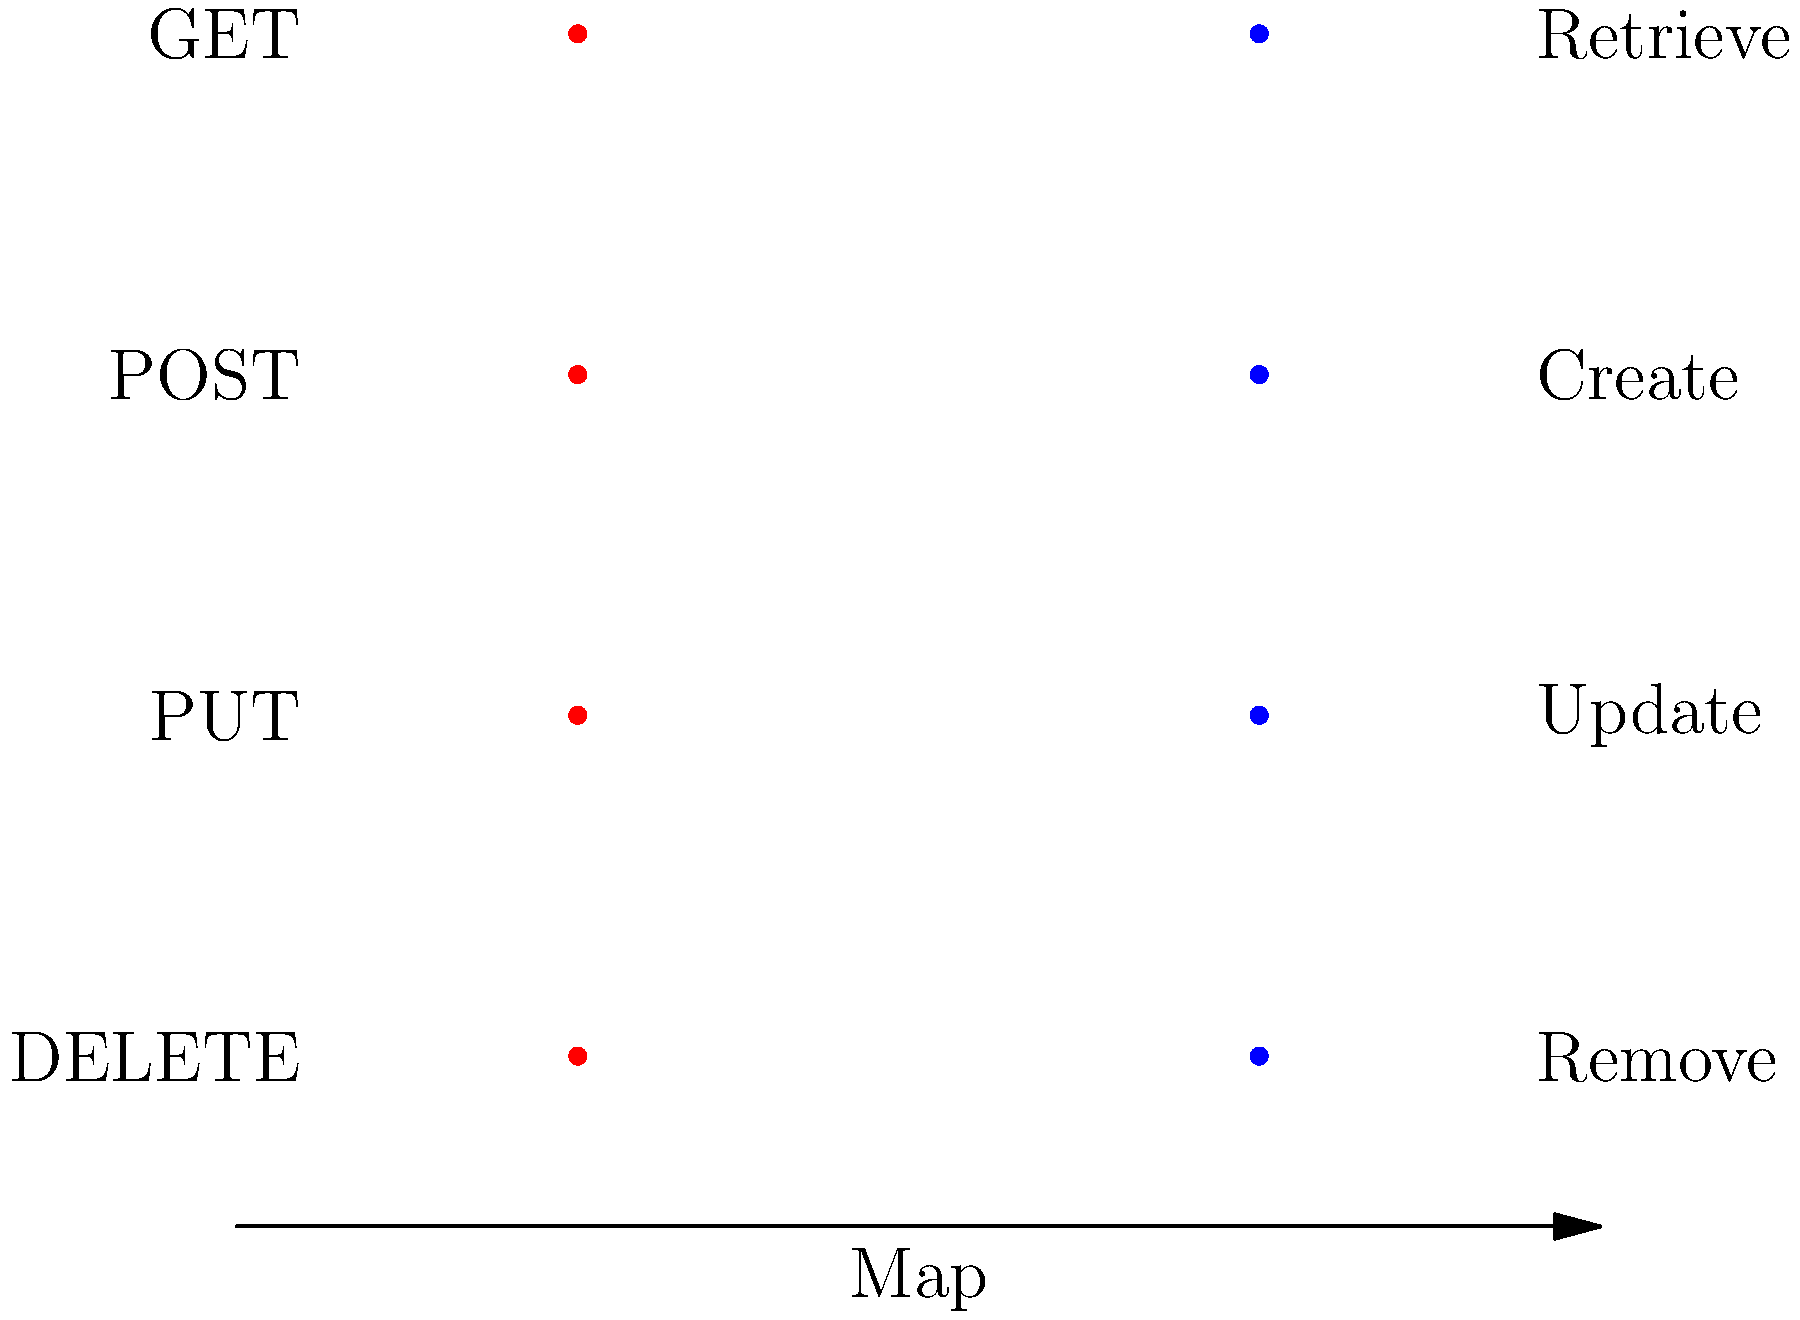In a web service integration scenario using Apache Synapse ESB, match the HTTP methods on the left with their corresponding SOAP operations on the right to ensure proper mapping in the service integration layer. To match HTTP methods with their corresponding SOAP operations in a web service integration scenario, follow these steps:

1. Understand the purpose of each HTTP method:
   - GET: Retrieve data
   - POST: Create new data
   - PUT: Update existing data
   - DELETE: Remove data

2. Understand the purpose of each SOAP operation:
   - Retrieve: Get existing data
   - Create: Add new data
   - Update: Modify existing data
   - Remove: Delete data

3. Map the HTTP methods to SOAP operations based on their similar purposes:
   - GET maps to Retrieve: Both are used to fetch existing data
   - POST maps to Create: Both are used to add new data
   - PUT maps to Update: Both are used to modify existing data
   - DELETE maps to Remove: Both are used to delete data

4. In Apache Synapse ESB, configure the integration layer to transform incoming HTTP requests to the appropriate SOAP operations:
   - Set up message mediation to map GET requests to Retrieve SOAP calls
   - Configure POST requests to trigger Create SOAP operations
   - Transform PUT requests into Update SOAP messages
   - Route DELETE requests to Remove SOAP actions

5. Ensure that the web service client sends the correct HTTP method for each desired operation, and that the ESB correctly translates these to the corresponding SOAP calls for the backend service.
Answer: GET-Retrieve, POST-Create, PUT-Update, DELETE-Remove 